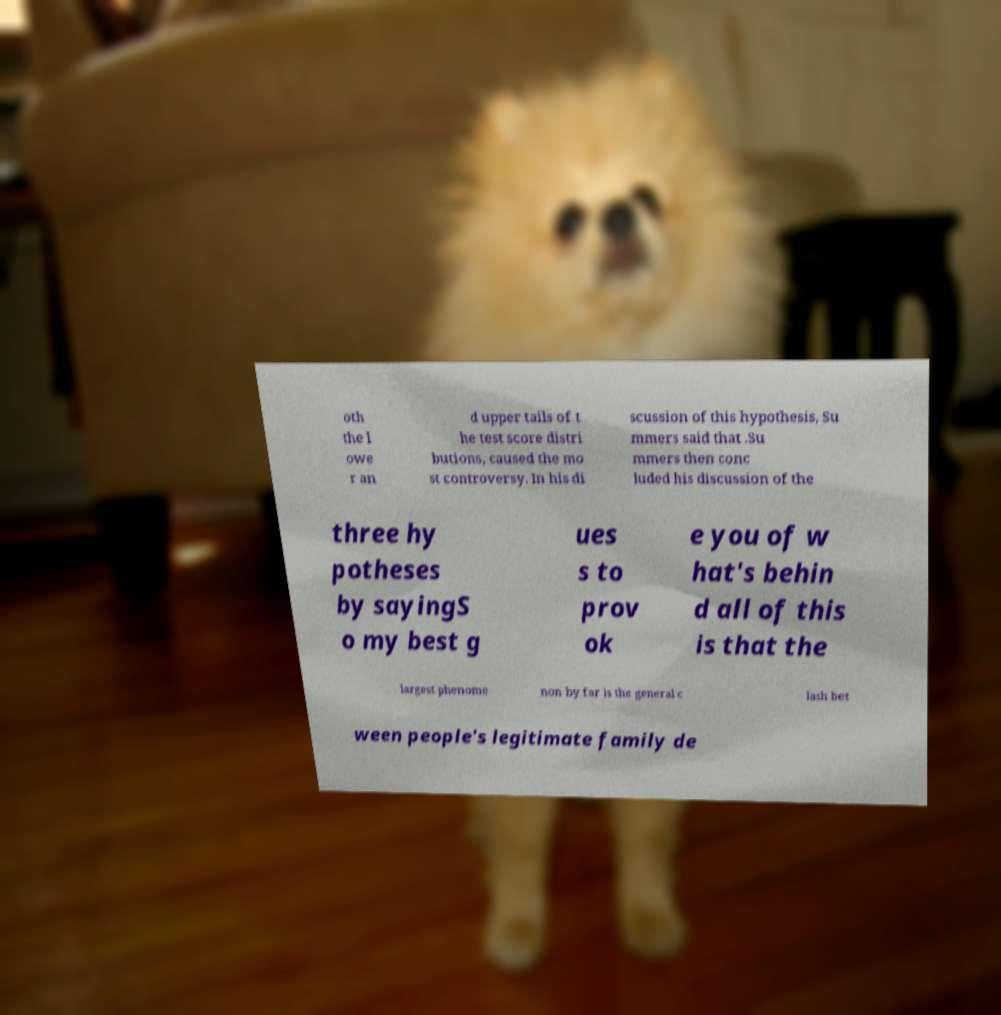Can you accurately transcribe the text from the provided image for me? oth the l owe r an d upper tails of t he test score distri butions, caused the mo st controversy. In his di scussion of this hypothesis, Su mmers said that .Su mmers then conc luded his discussion of the three hy potheses by sayingS o my best g ues s to prov ok e you of w hat's behin d all of this is that the largest phenome non by far is the general c lash bet ween people's legitimate family de 